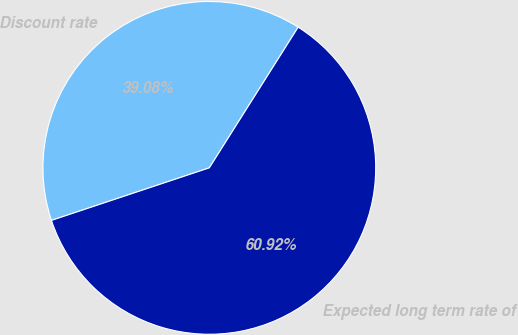<chart> <loc_0><loc_0><loc_500><loc_500><pie_chart><fcel>Discount rate<fcel>Expected long term rate of<nl><fcel>39.08%<fcel>60.92%<nl></chart> 